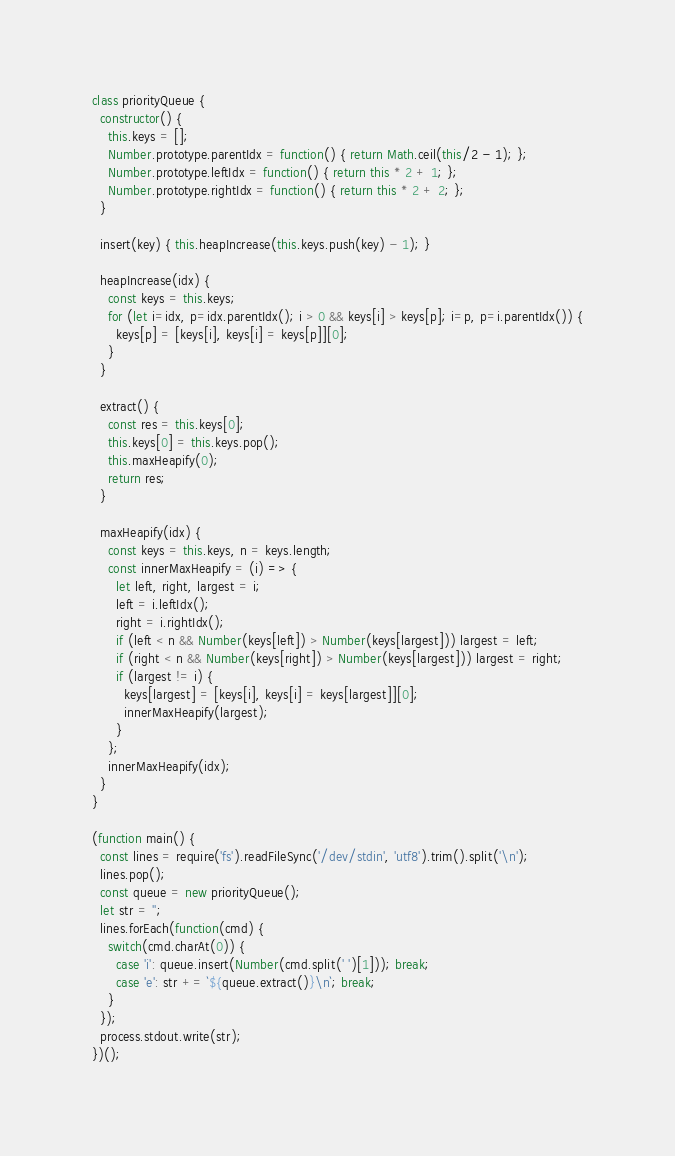Convert code to text. <code><loc_0><loc_0><loc_500><loc_500><_JavaScript_>class priorityQueue {
  constructor() {
    this.keys = [];
    Number.prototype.parentIdx = function() { return Math.ceil(this/2 - 1); };
    Number.prototype.leftIdx = function() { return this * 2 + 1; };
    Number.prototype.rightIdx = function() { return this * 2 + 2; };
  }

  insert(key) { this.heapIncrease(this.keys.push(key) - 1); }

  heapIncrease(idx) {
    const keys = this.keys;
    for (let i=idx, p=idx.parentIdx(); i > 0 && keys[i] > keys[p]; i=p, p=i.parentIdx()) {
      keys[p] = [keys[i], keys[i] = keys[p]][0];
    }
  }

  extract() {
    const res = this.keys[0];
    this.keys[0] = this.keys.pop();
    this.maxHeapify(0);
    return res;
  }

  maxHeapify(idx) {
    const keys = this.keys, n = keys.length;
    const innerMaxHeapify = (i) => {
      let left, right, largest = i;
      left = i.leftIdx();
      right = i.rightIdx();
      if (left < n && Number(keys[left]) > Number(keys[largest])) largest = left;
      if (right < n && Number(keys[right]) > Number(keys[largest])) largest = right;
      if (largest != i) {
        keys[largest] = [keys[i], keys[i] = keys[largest]][0];
        innerMaxHeapify(largest);
      }
    };
    innerMaxHeapify(idx);
  }
}

(function main() {
  const lines = require('fs').readFileSync('/dev/stdin', 'utf8').trim().split('\n');
  lines.pop();
  const queue = new priorityQueue();
  let str = '';
  lines.forEach(function(cmd) {
    switch(cmd.charAt(0)) {
      case 'i': queue.insert(Number(cmd.split(' ')[1])); break;
      case 'e': str += `${queue.extract()}\n`; break;
    }
  });
  process.stdout.write(str);
})();


</code> 